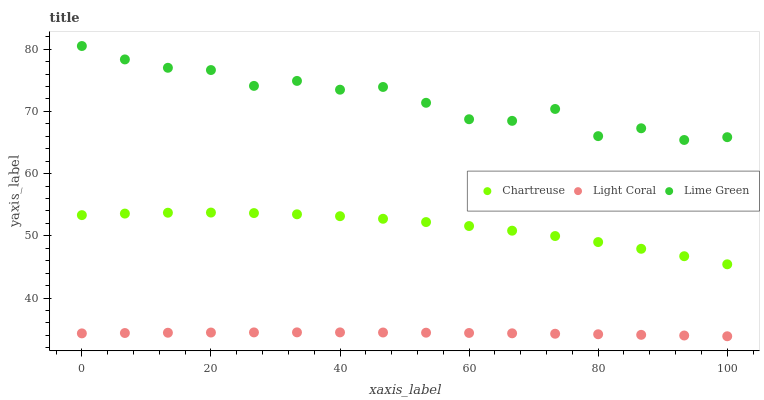Does Light Coral have the minimum area under the curve?
Answer yes or no. Yes. Does Lime Green have the maximum area under the curve?
Answer yes or no. Yes. Does Chartreuse have the minimum area under the curve?
Answer yes or no. No. Does Chartreuse have the maximum area under the curve?
Answer yes or no. No. Is Light Coral the smoothest?
Answer yes or no. Yes. Is Lime Green the roughest?
Answer yes or no. Yes. Is Chartreuse the smoothest?
Answer yes or no. No. Is Chartreuse the roughest?
Answer yes or no. No. Does Light Coral have the lowest value?
Answer yes or no. Yes. Does Chartreuse have the lowest value?
Answer yes or no. No. Does Lime Green have the highest value?
Answer yes or no. Yes. Does Chartreuse have the highest value?
Answer yes or no. No. Is Light Coral less than Lime Green?
Answer yes or no. Yes. Is Lime Green greater than Chartreuse?
Answer yes or no. Yes. Does Light Coral intersect Lime Green?
Answer yes or no. No. 